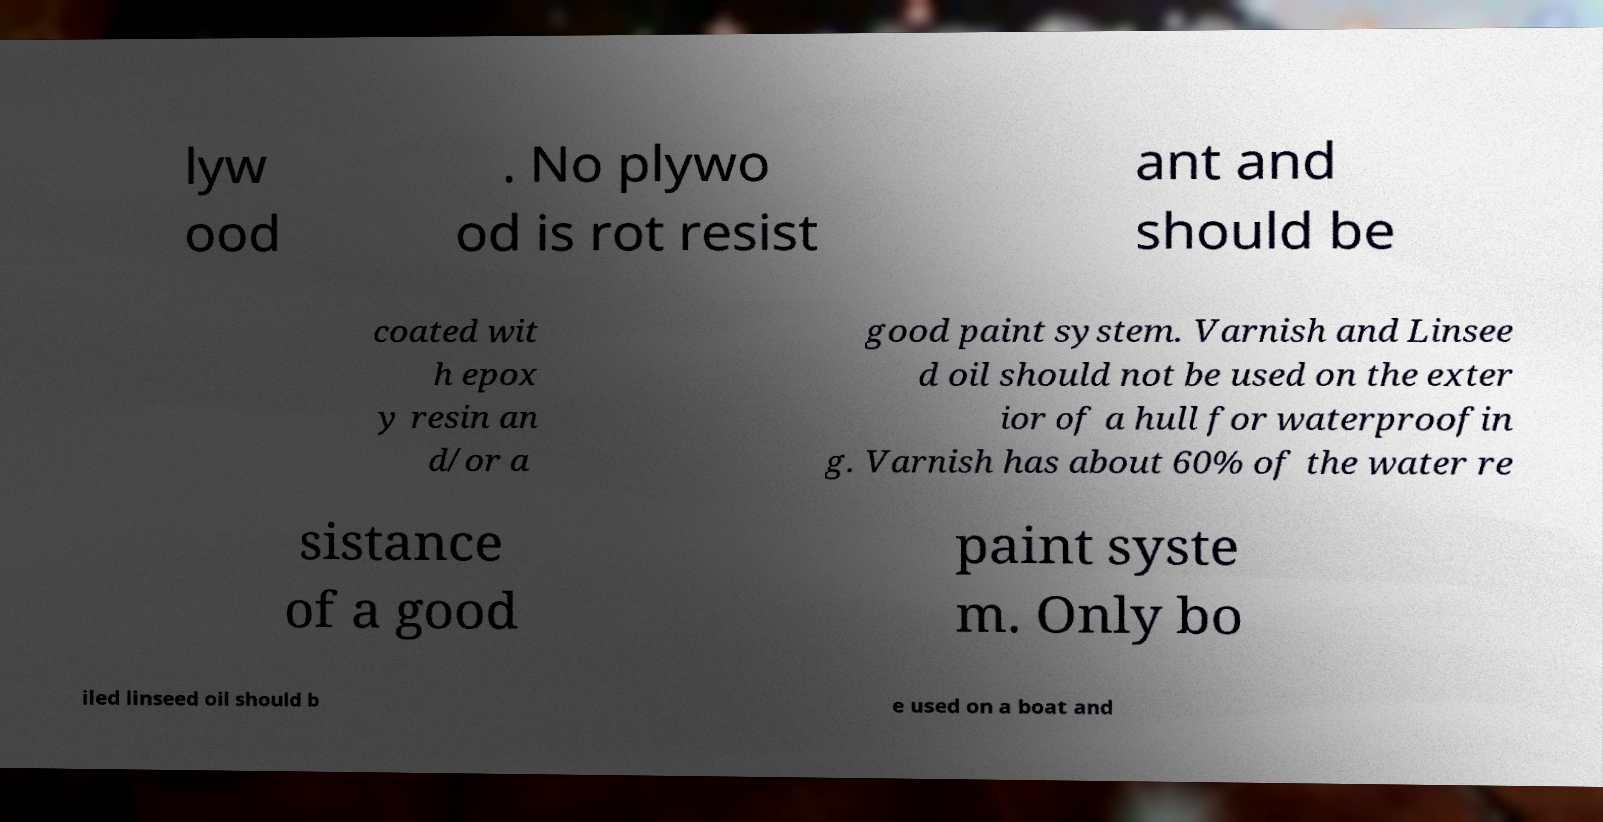Could you assist in decoding the text presented in this image and type it out clearly? lyw ood . No plywo od is rot resist ant and should be coated wit h epox y resin an d/or a good paint system. Varnish and Linsee d oil should not be used on the exter ior of a hull for waterproofin g. Varnish has about 60% of the water re sistance of a good paint syste m. Only bo iled linseed oil should b e used on a boat and 